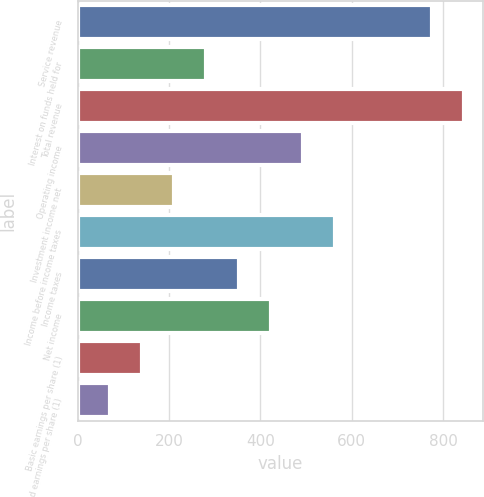Convert chart to OTSL. <chart><loc_0><loc_0><loc_500><loc_500><bar_chart><fcel>Service revenue<fcel>Interest on funds held for<fcel>Total revenue<fcel>Operating income<fcel>Investment income net<fcel>Income before income taxes<fcel>Income taxes<fcel>Net income<fcel>Basic earnings per share (1)<fcel>Diluted earnings per share (1)<nl><fcel>774.67<fcel>281.94<fcel>845.06<fcel>493.11<fcel>211.55<fcel>563.5<fcel>352.33<fcel>422.72<fcel>141.16<fcel>70.77<nl></chart> 